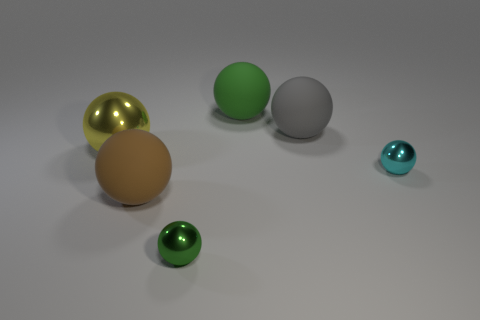Subtract all cyan balls. How many balls are left? 5 Subtract all green spheres. How many spheres are left? 4 Subtract 1 spheres. How many spheres are left? 5 Add 2 big gray things. How many objects exist? 8 Subtract all brown cubes. How many gray balls are left? 1 Add 1 tiny metal objects. How many tiny metal objects are left? 3 Add 4 big gray rubber spheres. How many big gray rubber spheres exist? 5 Subtract 0 green cylinders. How many objects are left? 6 Subtract all red spheres. Subtract all cyan blocks. How many spheres are left? 6 Subtract all tiny cyan metallic things. Subtract all green metal balls. How many objects are left? 4 